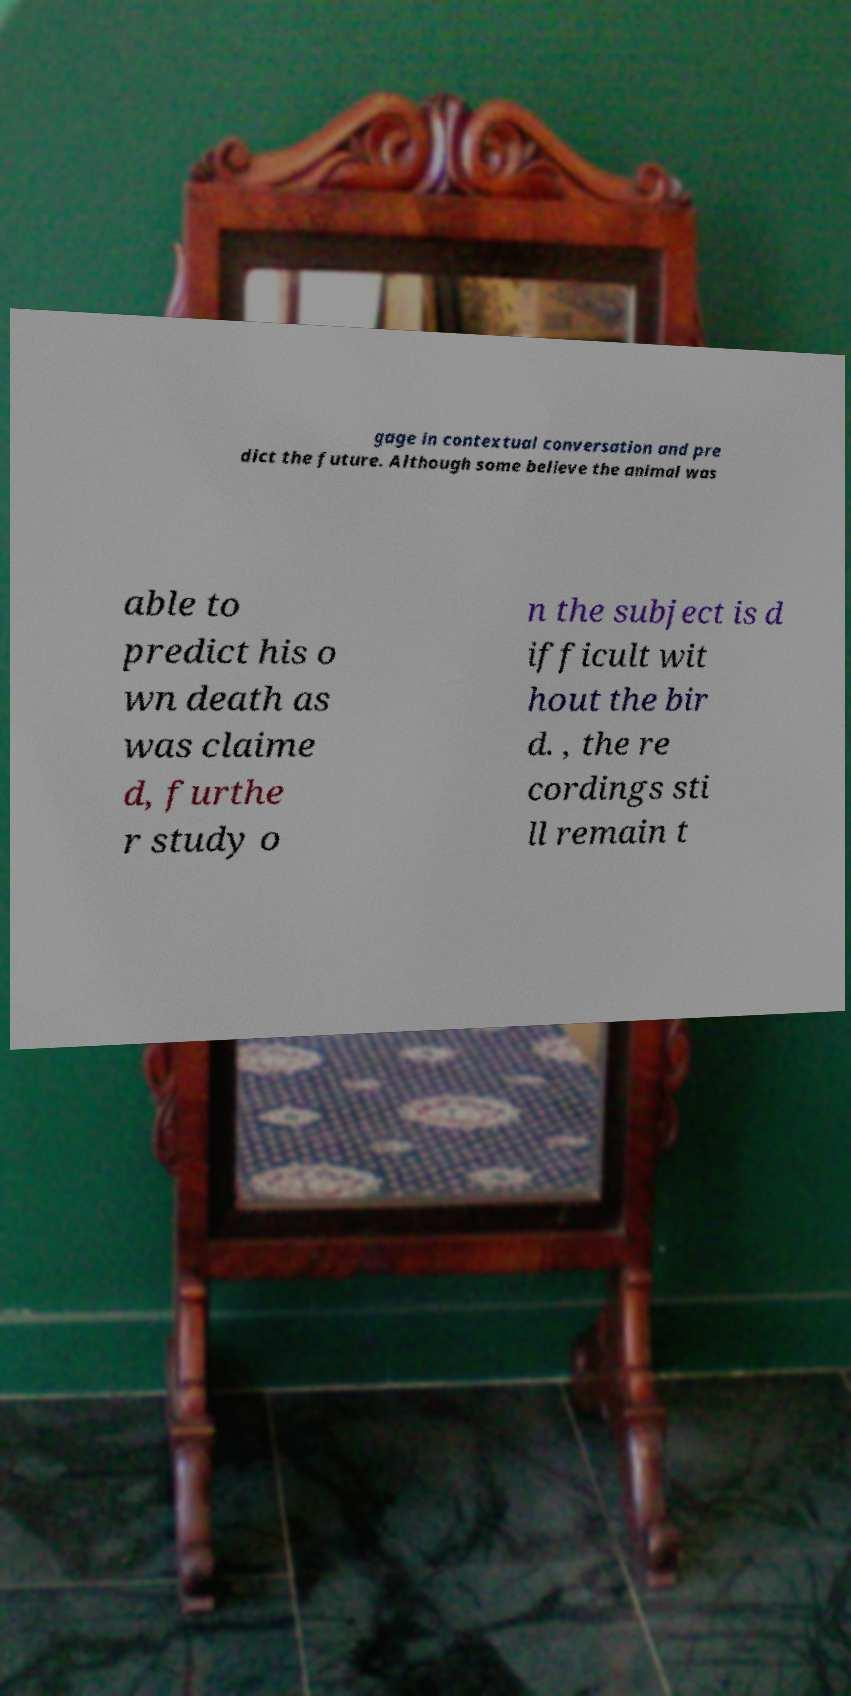I need the written content from this picture converted into text. Can you do that? gage in contextual conversation and pre dict the future. Although some believe the animal was able to predict his o wn death as was claime d, furthe r study o n the subject is d ifficult wit hout the bir d. , the re cordings sti ll remain t 